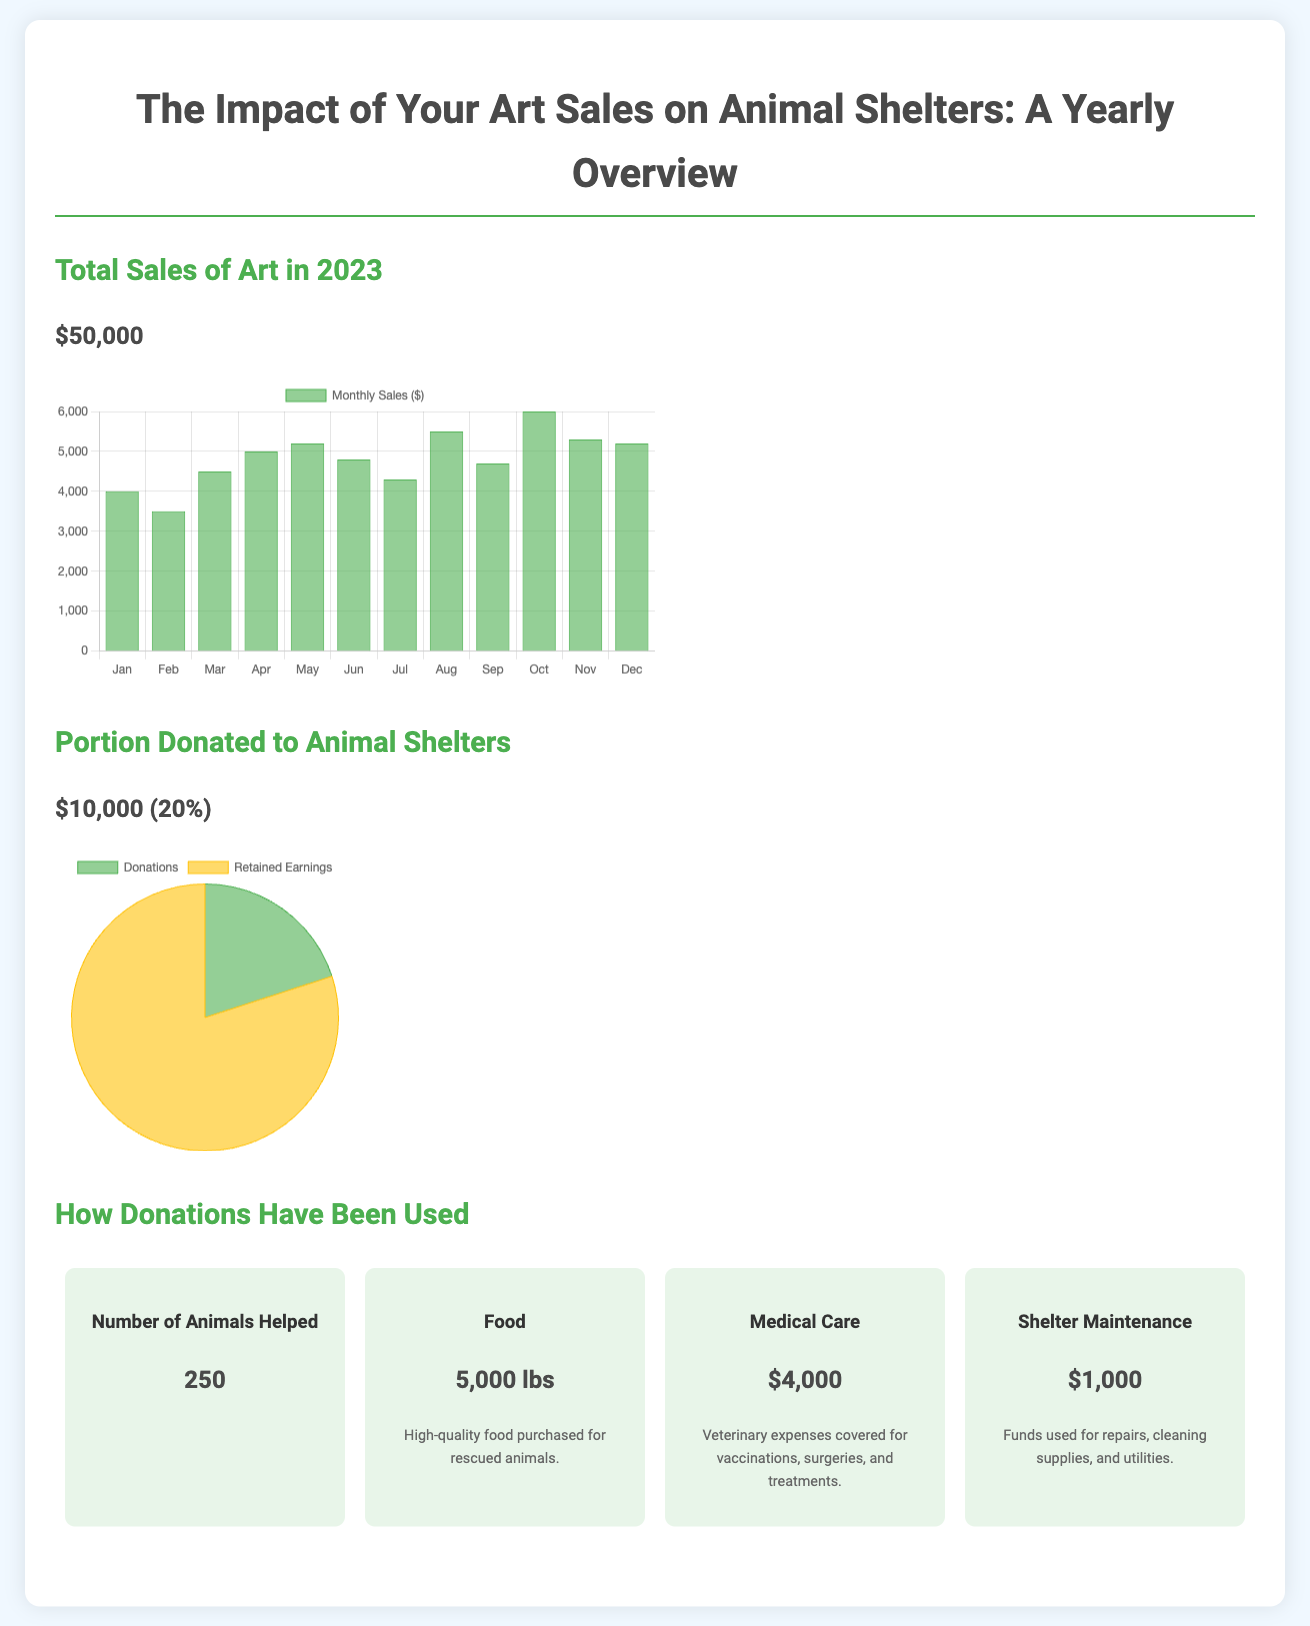what are the total art sales in 2023? The total art sales is stated directly in the document as $50,000.
Answer: $50,000 how much was donated to animal shelters? The donation amount is highlighted in the document as $10,000.
Answer: $10,000 what percentage of art sales was donated? The document specifies that 20% of the total art sales were donated.
Answer: 20% how many animals were helped by the donations? The document states that 250 animals were helped using the donations made.
Answer: 250 what expenses were covered for medical care? The document indicates that $4,000 was allocated for veterinary expenses.
Answer: $4,000 how many pounds of food were purchased for animals? According to the document, 5,000 lbs of food were purchased for the animals.
Answer: 5,000 lbs what was the amount used for shelter maintenance? The document reveals that $1,000 was used for shelter maintenance expenses.
Answer: $1,000 which month had the highest sales? The sales data indicates that June had the highest sales at $6,000.
Answer: June how are the donations represented visually in the infographic? The donation portion is visualized using a pie chart.
Answer: pie chart 